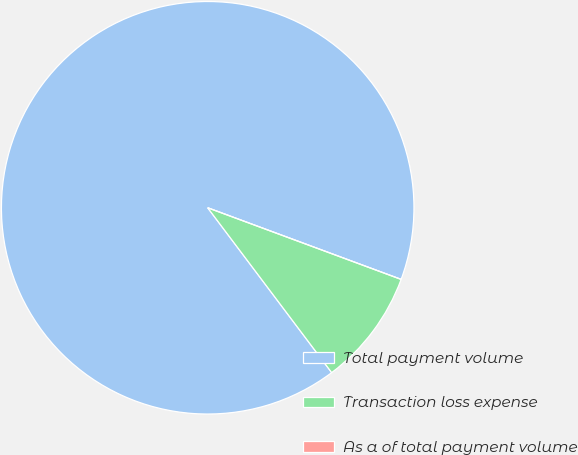<chart> <loc_0><loc_0><loc_500><loc_500><pie_chart><fcel>Total payment volume<fcel>Transaction loss expense<fcel>As a of total payment volume<nl><fcel>90.91%<fcel>9.09%<fcel>0.0%<nl></chart> 